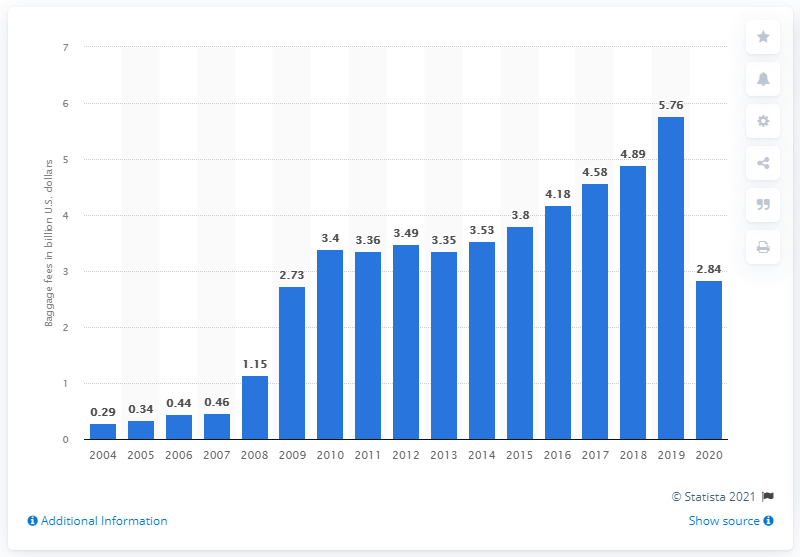Point out several critical features in this image. In 2020, the amount of money that passengers paid in baggage fees in the United States was approximately 2.84 billion dollars. 